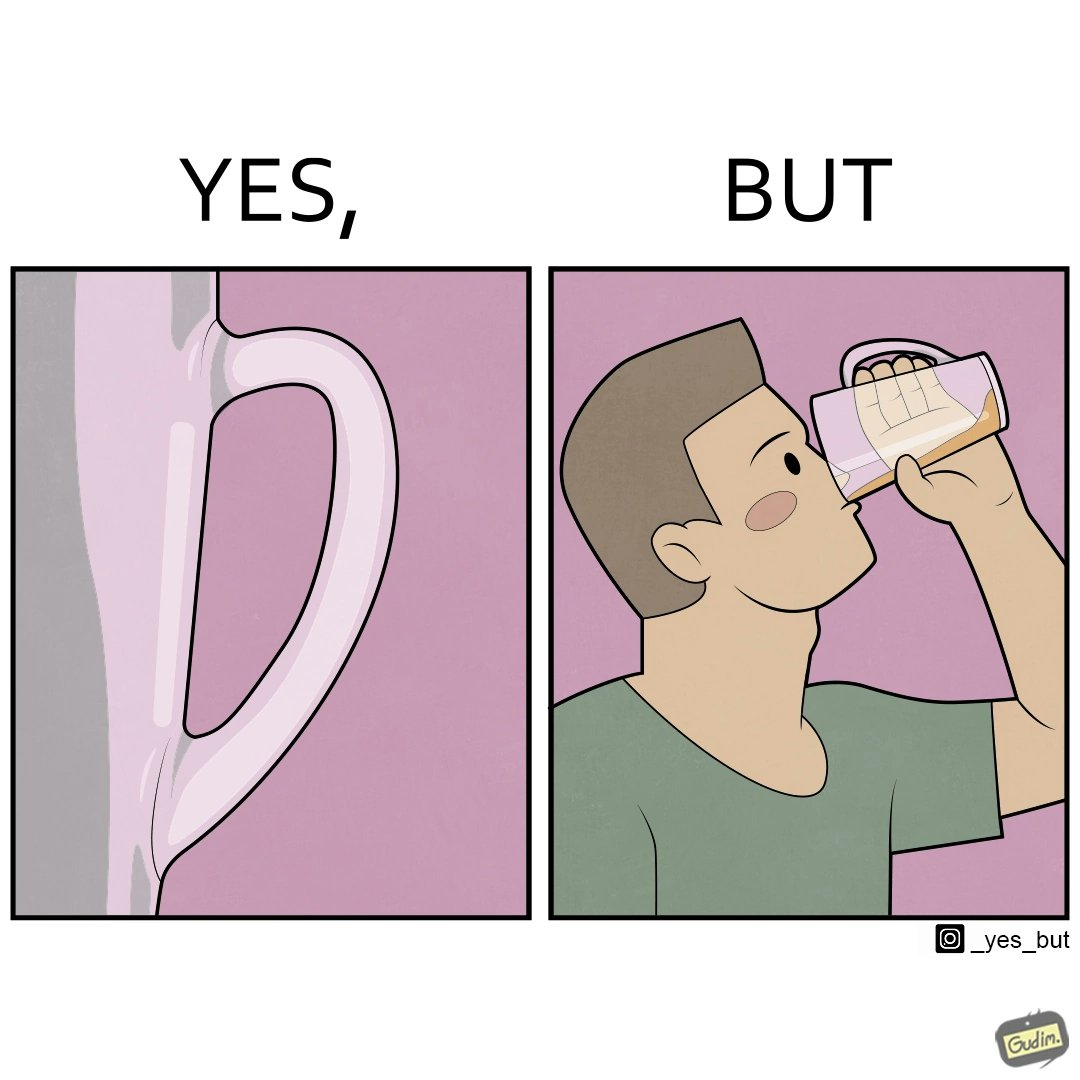What is shown in this image? This image is funny because even though the tumbler has a glass handle on it to facilitate holding, the person drinking from it doesn't use the handle making it redundant. 